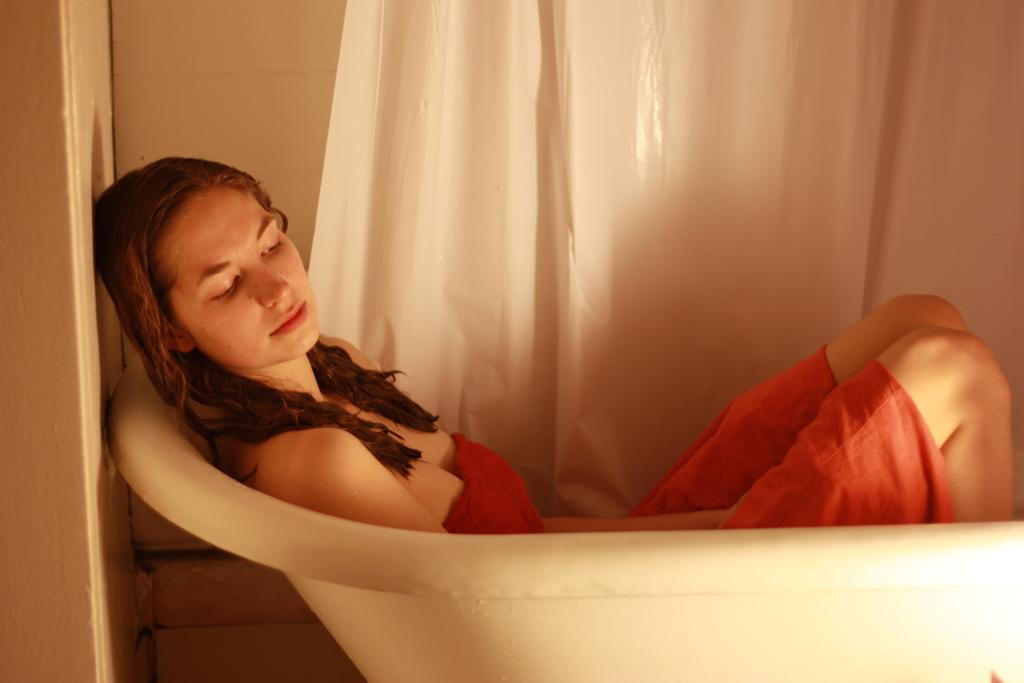Who is present in the image? There is a woman in the image. What is the woman doing in the image? The woman is laying in a bathtub. What can be seen in the background of the image? There is a white curtain in the background of the image. How does the earthquake affect the woman in the image? There is no earthquake present in the image, so its effect on the woman cannot be determined. 